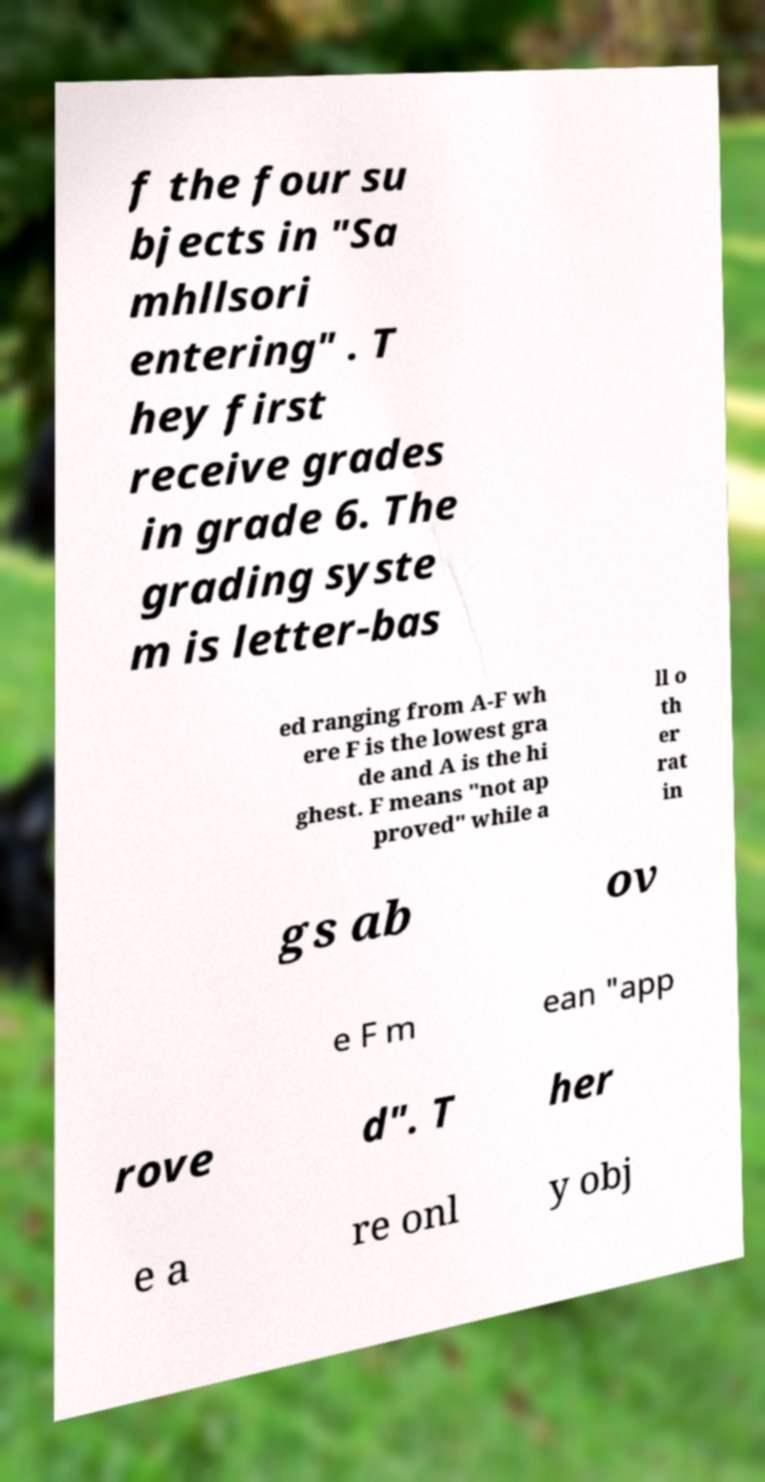Could you extract and type out the text from this image? f the four su bjects in "Sa mhllsori entering" . T hey first receive grades in grade 6. The grading syste m is letter-bas ed ranging from A-F wh ere F is the lowest gra de and A is the hi ghest. F means "not ap proved" while a ll o th er rat in gs ab ov e F m ean "app rove d". T her e a re onl y obj 